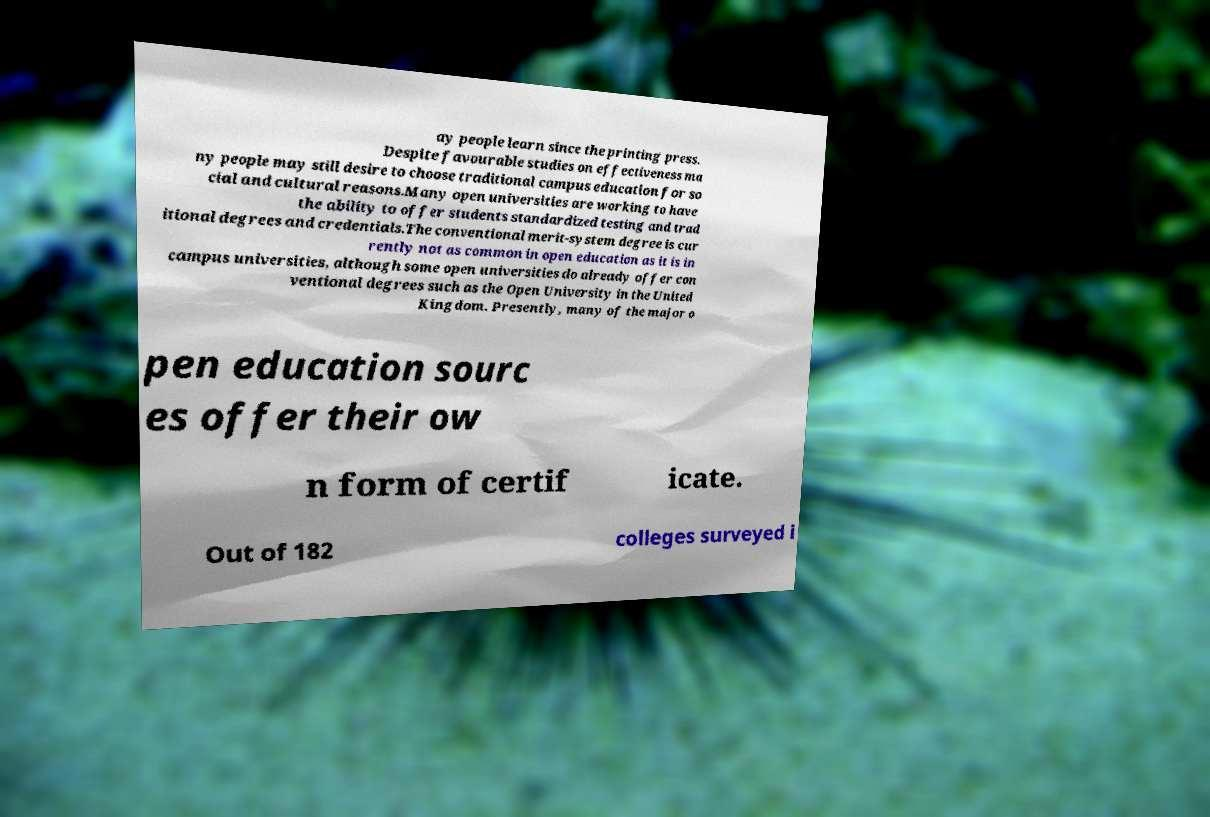Can you read and provide the text displayed in the image?This photo seems to have some interesting text. Can you extract and type it out for me? ay people learn since the printing press. Despite favourable studies on effectiveness ma ny people may still desire to choose traditional campus education for so cial and cultural reasons.Many open universities are working to have the ability to offer students standardized testing and trad itional degrees and credentials.The conventional merit-system degree is cur rently not as common in open education as it is in campus universities, although some open universities do already offer con ventional degrees such as the Open University in the United Kingdom. Presently, many of the major o pen education sourc es offer their ow n form of certif icate. Out of 182 colleges surveyed i 